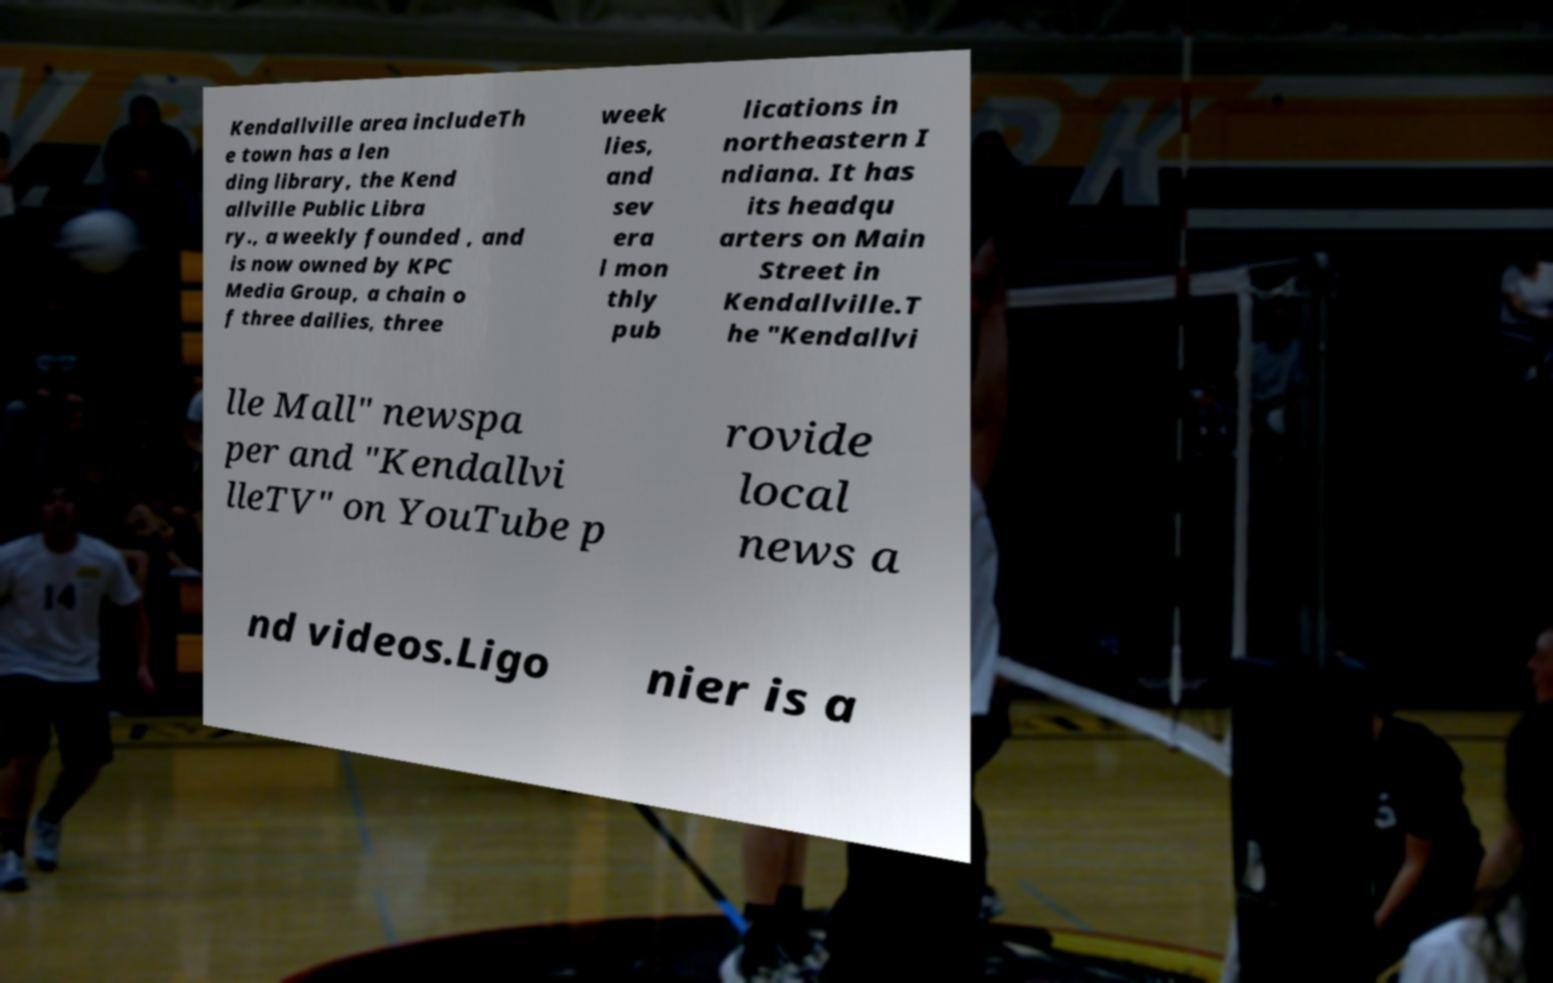Could you assist in decoding the text presented in this image and type it out clearly? Kendallville area includeTh e town has a len ding library, the Kend allville Public Libra ry., a weekly founded , and is now owned by KPC Media Group, a chain o f three dailies, three week lies, and sev era l mon thly pub lications in northeastern I ndiana. It has its headqu arters on Main Street in Kendallville.T he "Kendallvi lle Mall" newspa per and "Kendallvi lleTV" on YouTube p rovide local news a nd videos.Ligo nier is a 